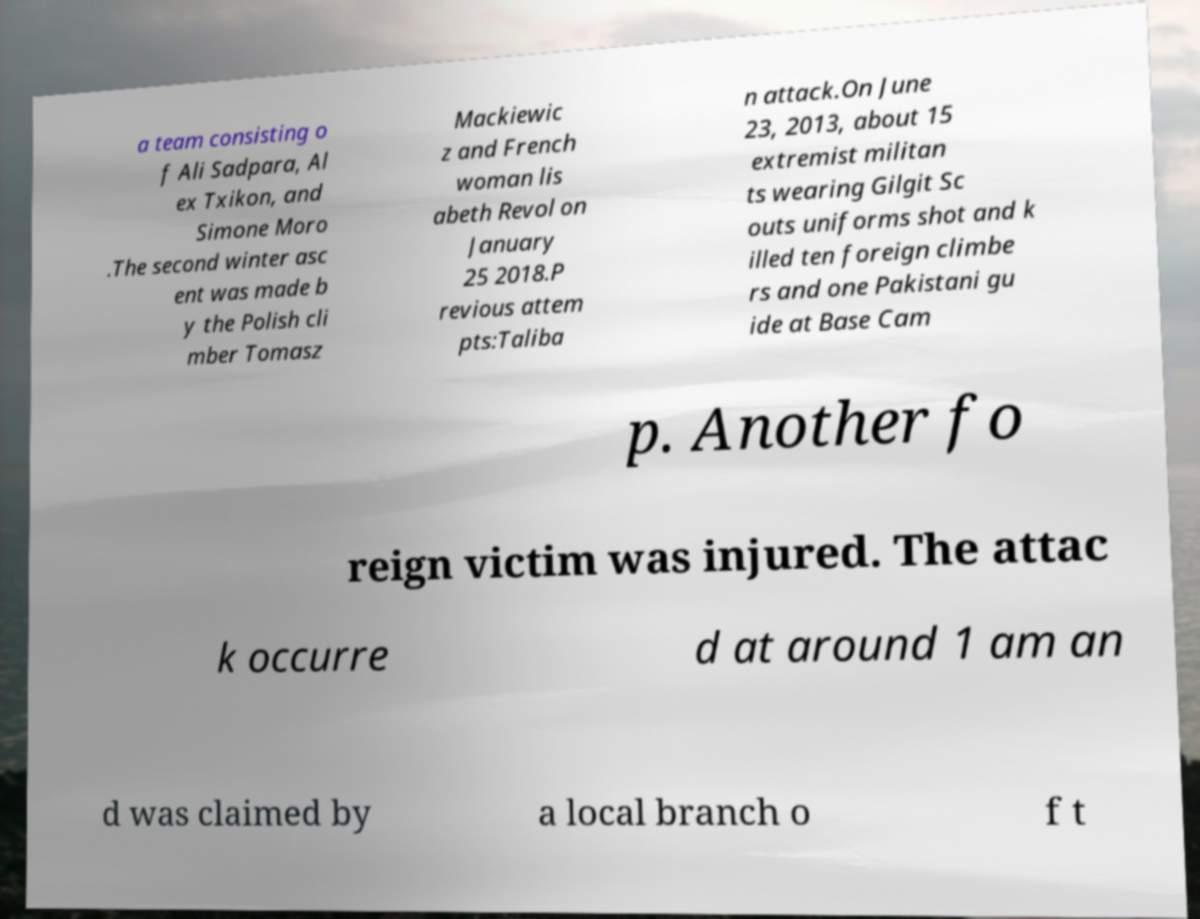I need the written content from this picture converted into text. Can you do that? a team consisting o f Ali Sadpara, Al ex Txikon, and Simone Moro .The second winter asc ent was made b y the Polish cli mber Tomasz Mackiewic z and French woman lis abeth Revol on January 25 2018.P revious attem pts:Taliba n attack.On June 23, 2013, about 15 extremist militan ts wearing Gilgit Sc outs uniforms shot and k illed ten foreign climbe rs and one Pakistani gu ide at Base Cam p. Another fo reign victim was injured. The attac k occurre d at around 1 am an d was claimed by a local branch o f t 